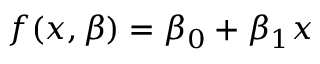<formula> <loc_0><loc_0><loc_500><loc_500>f ( x , { \beta } ) = \beta _ { 0 } + \beta _ { 1 } x</formula> 